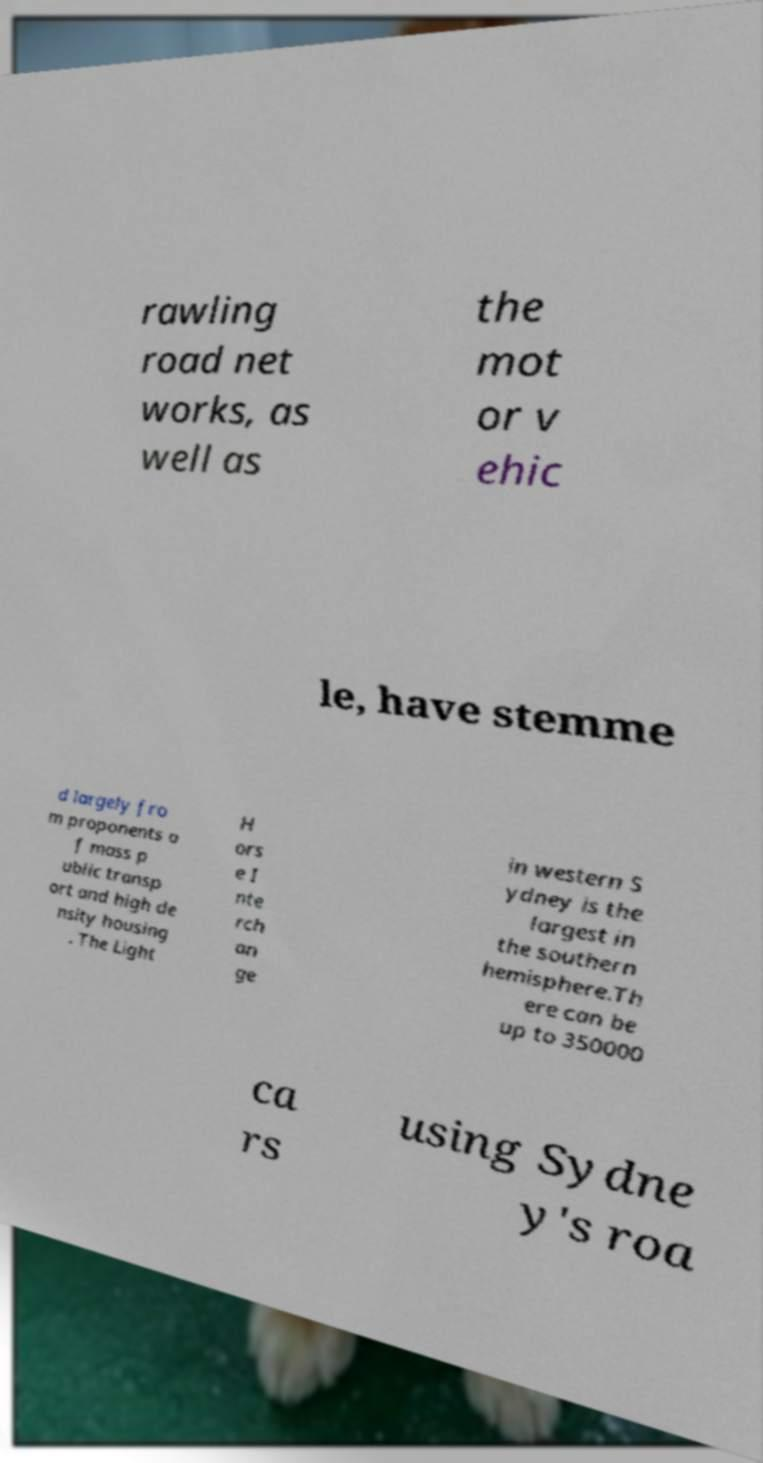Please identify and transcribe the text found in this image. rawling road net works, as well as the mot or v ehic le, have stemme d largely fro m proponents o f mass p ublic transp ort and high de nsity housing . The Light H ors e I nte rch an ge in western S ydney is the largest in the southern hemisphere.Th ere can be up to 350000 ca rs using Sydne y's roa 